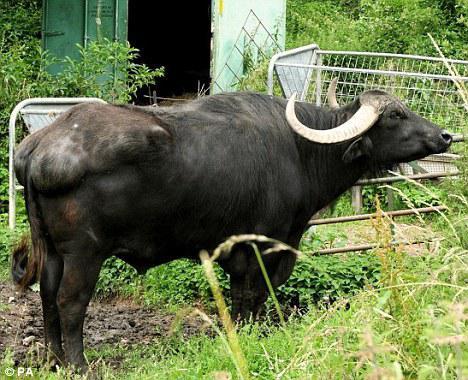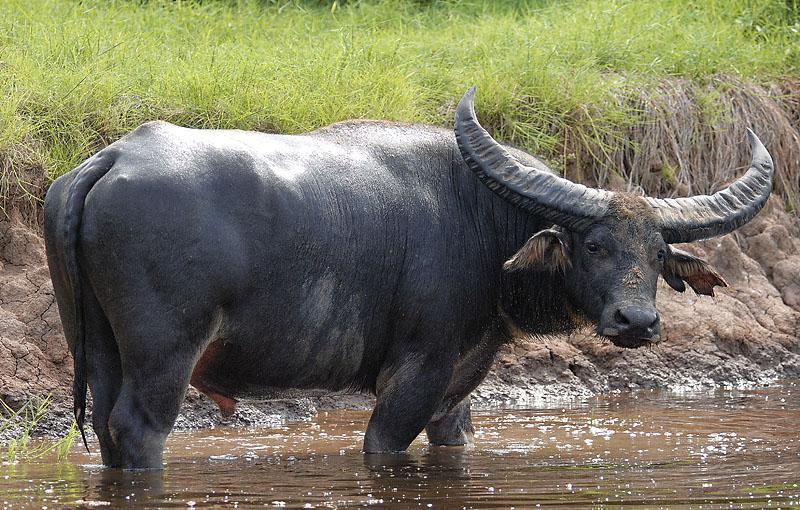The first image is the image on the left, the second image is the image on the right. Considering the images on both sides, is "In one of the image a water buffalo is standing in the water." valid? Answer yes or no. Yes. The first image is the image on the left, the second image is the image on the right. Examine the images to the left and right. Is the description "At least one image shows a buffalo in the water." accurate? Answer yes or no. Yes. 